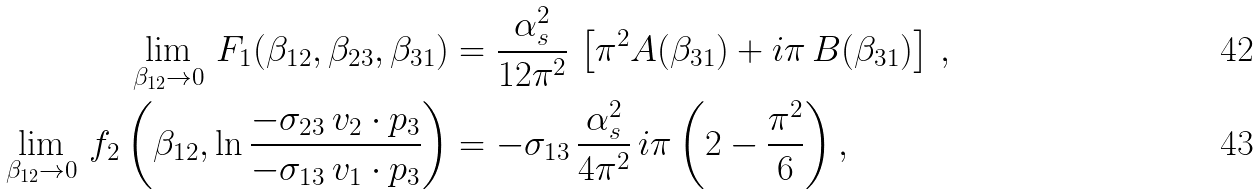<formula> <loc_0><loc_0><loc_500><loc_500>\lim _ { \beta _ { 1 2 } \to 0 } \, F _ { 1 } ( \beta _ { 1 2 } , \beta _ { 2 3 } , \beta _ { 3 1 } ) & = \frac { \alpha _ { s } ^ { 2 } } { 1 2 \pi ^ { 2 } } \, \left [ \pi ^ { 2 } A ( \beta _ { 3 1 } ) + i \pi \, B ( \beta _ { 3 1 } ) \right ] \, , \\ \lim _ { \beta _ { 1 2 } \to 0 } \, f _ { 2 } \left ( \beta _ { 1 2 } , \ln \frac { - \sigma _ { 2 3 } \, v _ { 2 } \cdot p _ { 3 } } { - \sigma _ { 1 3 } \, v _ { 1 } \cdot p _ { 3 } } \right ) & = - \sigma _ { 1 3 } \, \frac { \alpha _ { s } ^ { 2 } } { 4 \pi ^ { 2 } } \, i \pi \left ( 2 - \frac { \pi ^ { 2 } } { 6 } \right ) ,</formula> 